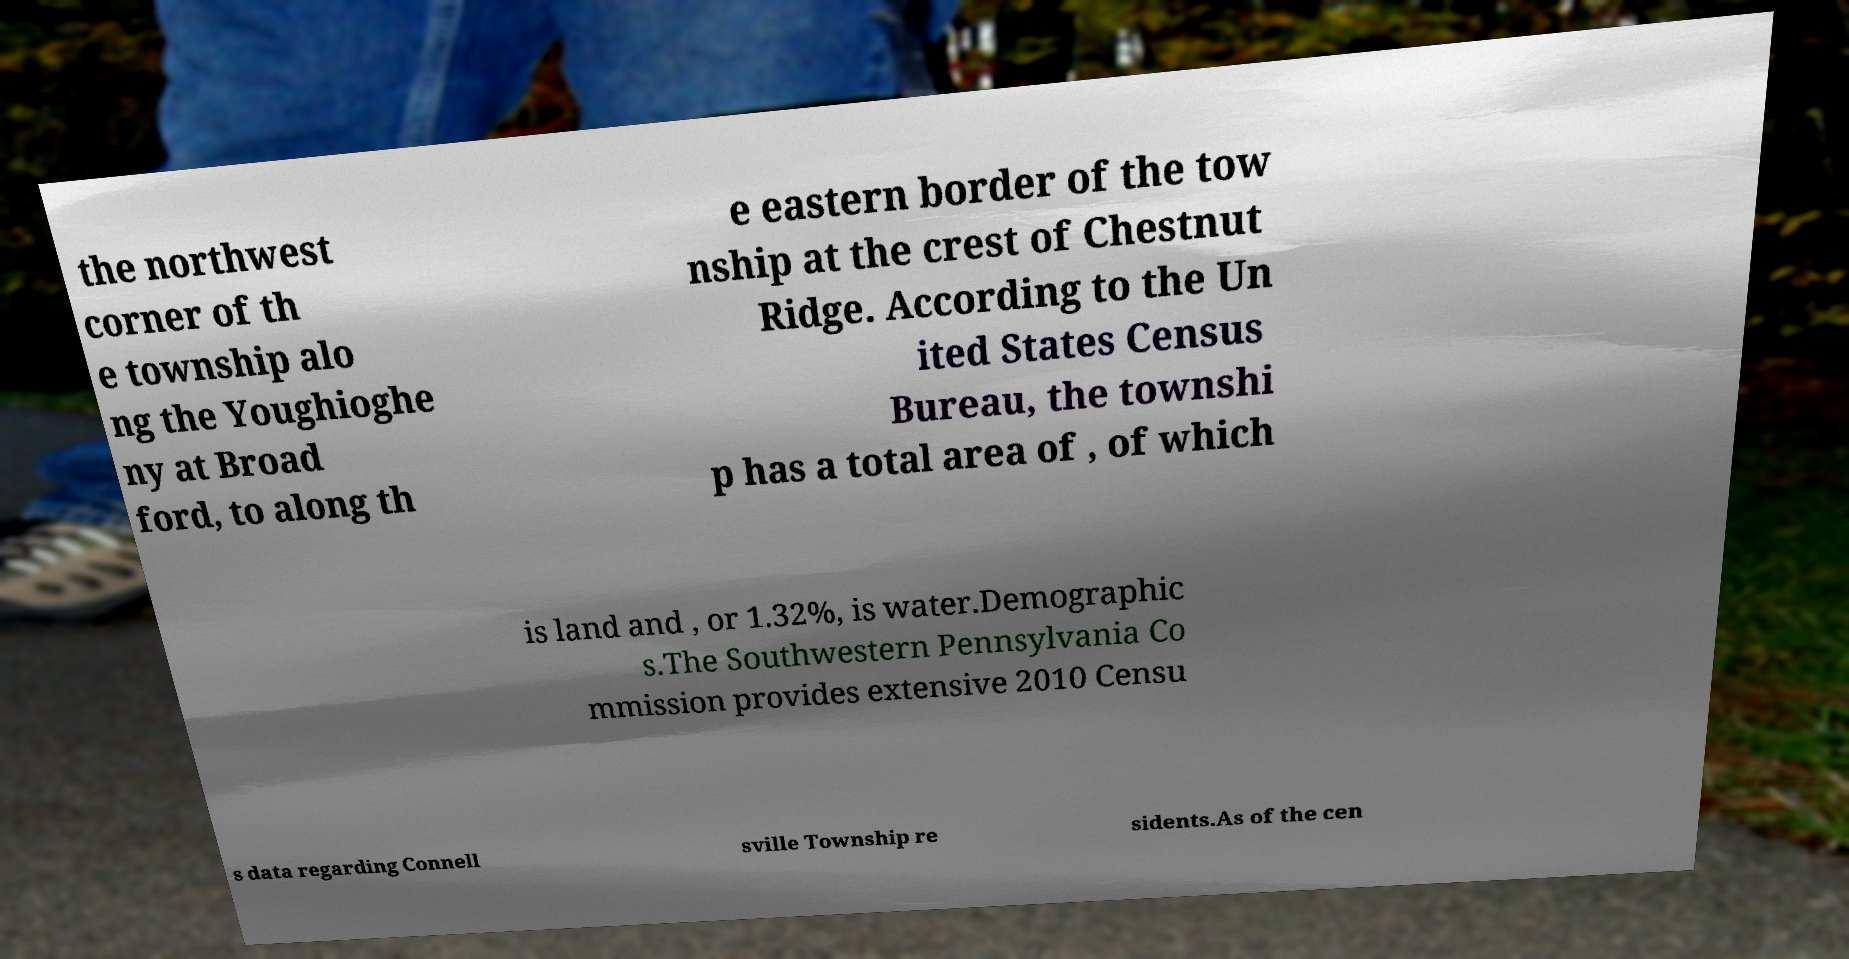There's text embedded in this image that I need extracted. Can you transcribe it verbatim? the northwest corner of th e township alo ng the Youghioghe ny at Broad ford, to along th e eastern border of the tow nship at the crest of Chestnut Ridge. According to the Un ited States Census Bureau, the townshi p has a total area of , of which is land and , or 1.32%, is water.Demographic s.The Southwestern Pennsylvania Co mmission provides extensive 2010 Censu s data regarding Connell sville Township re sidents.As of the cen 